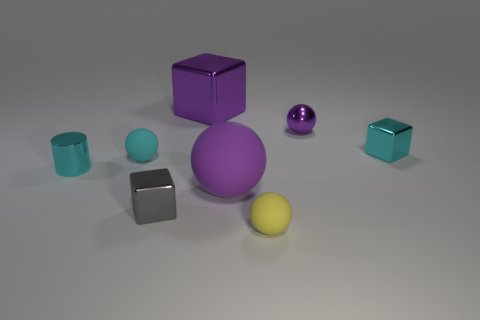How many metallic things are gray cubes or yellow spheres?
Keep it short and to the point. 1. Is the small thing that is in front of the gray cube made of the same material as the purple sphere to the left of the yellow ball?
Ensure brevity in your answer.  Yes. What is the color of the large sphere that is the same material as the yellow thing?
Provide a short and direct response. Purple. Is the number of metal blocks that are behind the cyan rubber ball greater than the number of cylinders behind the small shiny sphere?
Make the answer very short. Yes. Is there a tiny cyan thing?
Offer a very short reply. Yes. There is another big ball that is the same color as the metallic sphere; what is it made of?
Give a very brief answer. Rubber. How many objects are either tiny blue objects or tiny gray metal things?
Keep it short and to the point. 1. Are there any big objects of the same color as the large cube?
Offer a terse response. Yes. There is a large object that is in front of the small cyan matte sphere; what number of shiny things are behind it?
Your answer should be compact. 4. Are there more large purple cubes than large blue matte spheres?
Give a very brief answer. Yes. 